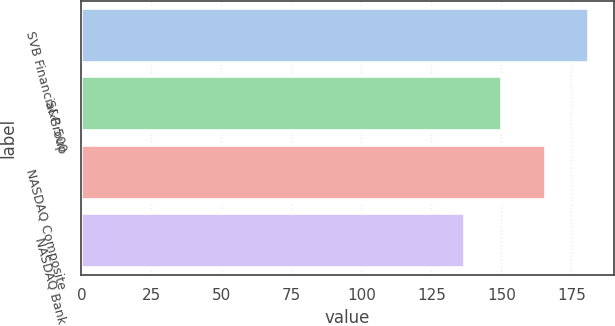<chart> <loc_0><loc_0><loc_500><loc_500><bar_chart><fcel>SVB Financial Group<fcel>S&P 500<fcel>NASDAQ Composite<fcel>NASDAQ Bank<nl><fcel>181.12<fcel>150.33<fcel>165.84<fcel>136.99<nl></chart> 